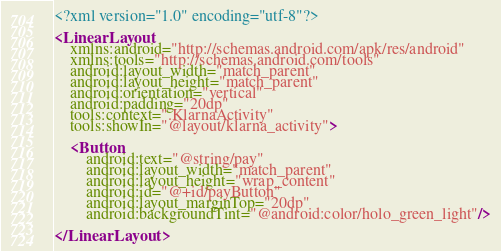Convert code to text. <code><loc_0><loc_0><loc_500><loc_500><_XML_><?xml version="1.0" encoding="utf-8"?>

<LinearLayout
    xmlns:android="http://schemas.android.com/apk/res/android"
    xmlns:tools="http://schemas.android.com/tools"
    android:layout_width="match_parent"
    android:layout_height="match_parent"
    android:orientation="vertical"
    android:padding="20dp"
    tools:context=".KlarnaActivity"
    tools:showIn="@layout/klarna_activity">

    <Button
        android:text="@string/pay"
        android:layout_width="match_parent"
        android:layout_height="wrap_content"
        android:id="@+id/payButton"
        android:layout_marginTop="20dp"
        android:backgroundTint="@android:color/holo_green_light"/>

</LinearLayout>
</code> 